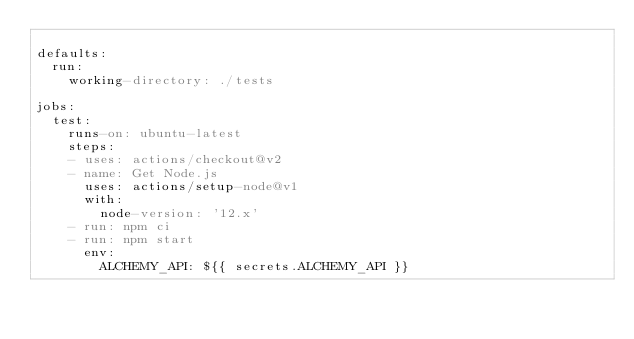<code> <loc_0><loc_0><loc_500><loc_500><_YAML_>    
defaults:
  run:
    working-directory: ./tests    

jobs:
  test:
    runs-on: ubuntu-latest
    steps:
    - uses: actions/checkout@v2
    - name: Get Node.js
      uses: actions/setup-node@v1
      with:
        node-version: '12.x'
    - run: npm ci
    - run: npm start
      env:
        ALCHEMY_API: ${{ secrets.ALCHEMY_API }}
</code> 